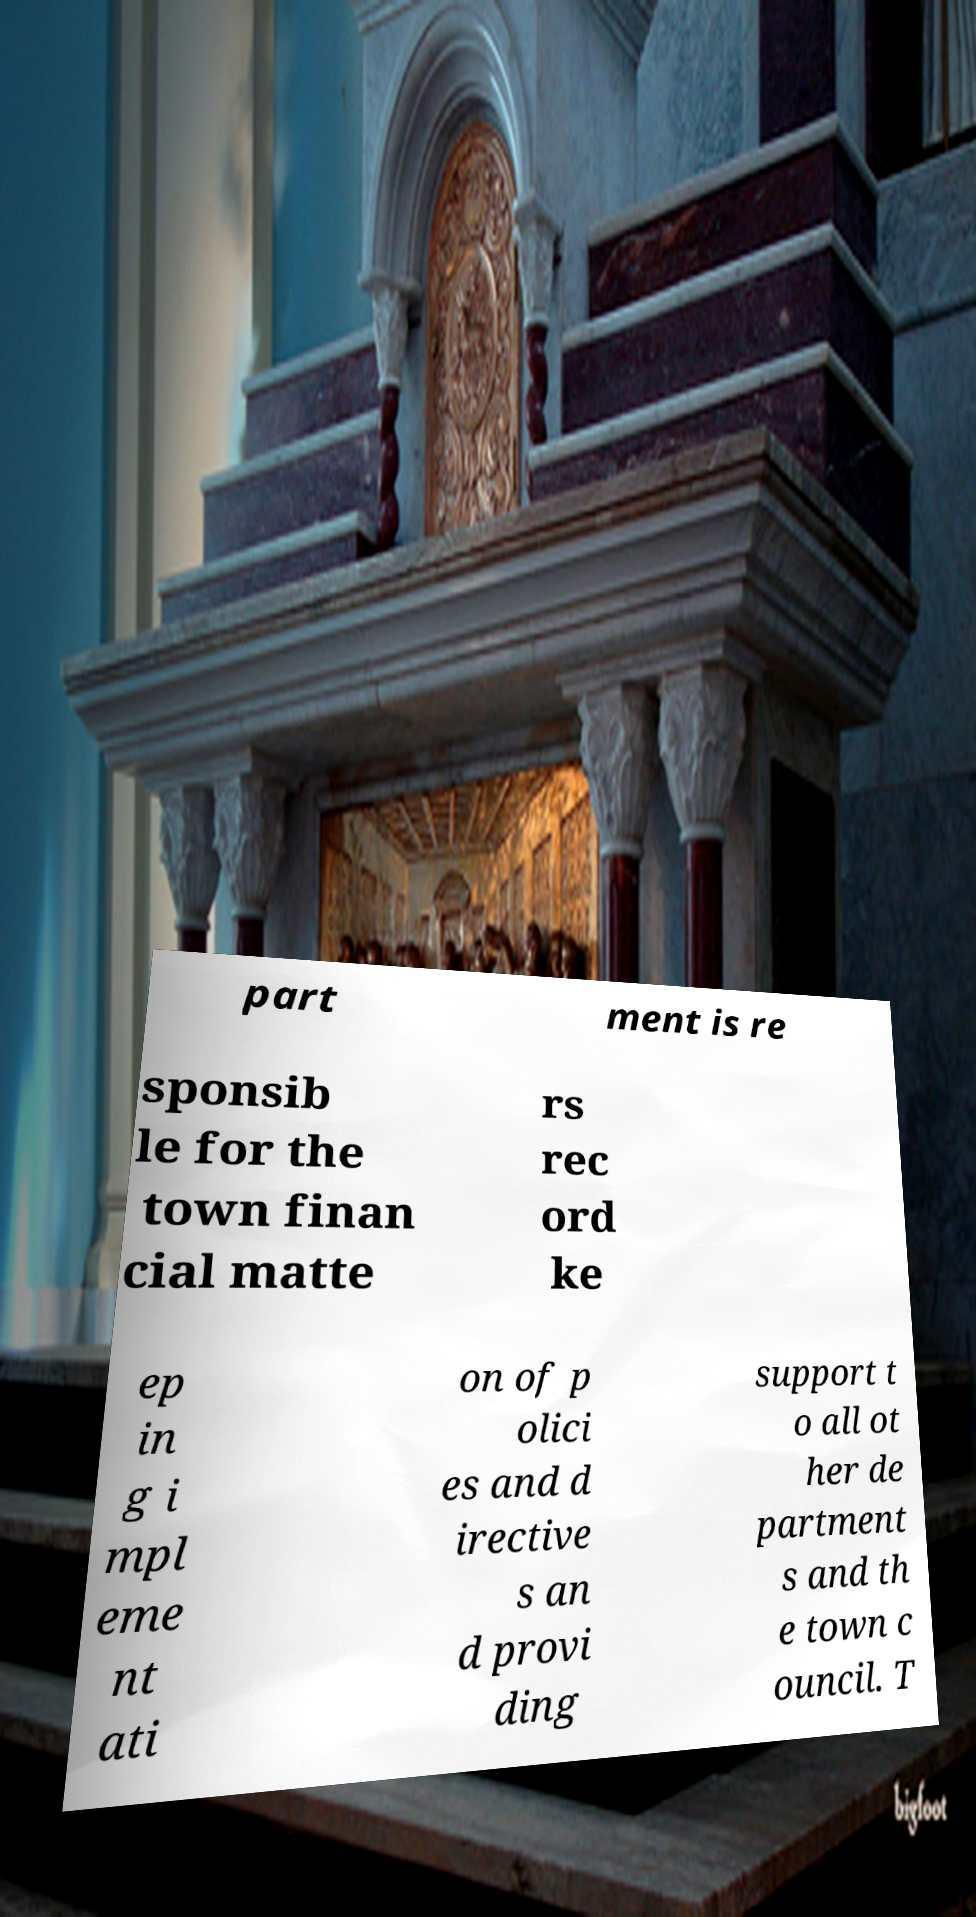What messages or text are displayed in this image? I need them in a readable, typed format. part ment is re sponsib le for the town finan cial matte rs rec ord ke ep in g i mpl eme nt ati on of p olici es and d irective s an d provi ding support t o all ot her de partment s and th e town c ouncil. T 